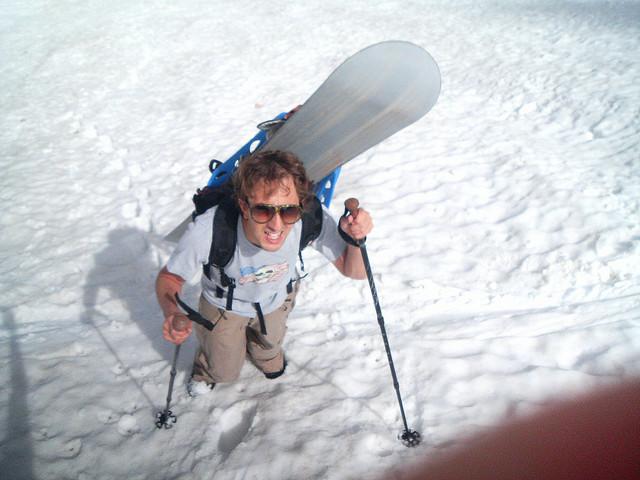Is this man a professional snowboarder?
Quick response, please. No. What is the weather?
Quick response, please. Cold. What is on this man's back?
Give a very brief answer. Snowboard. 